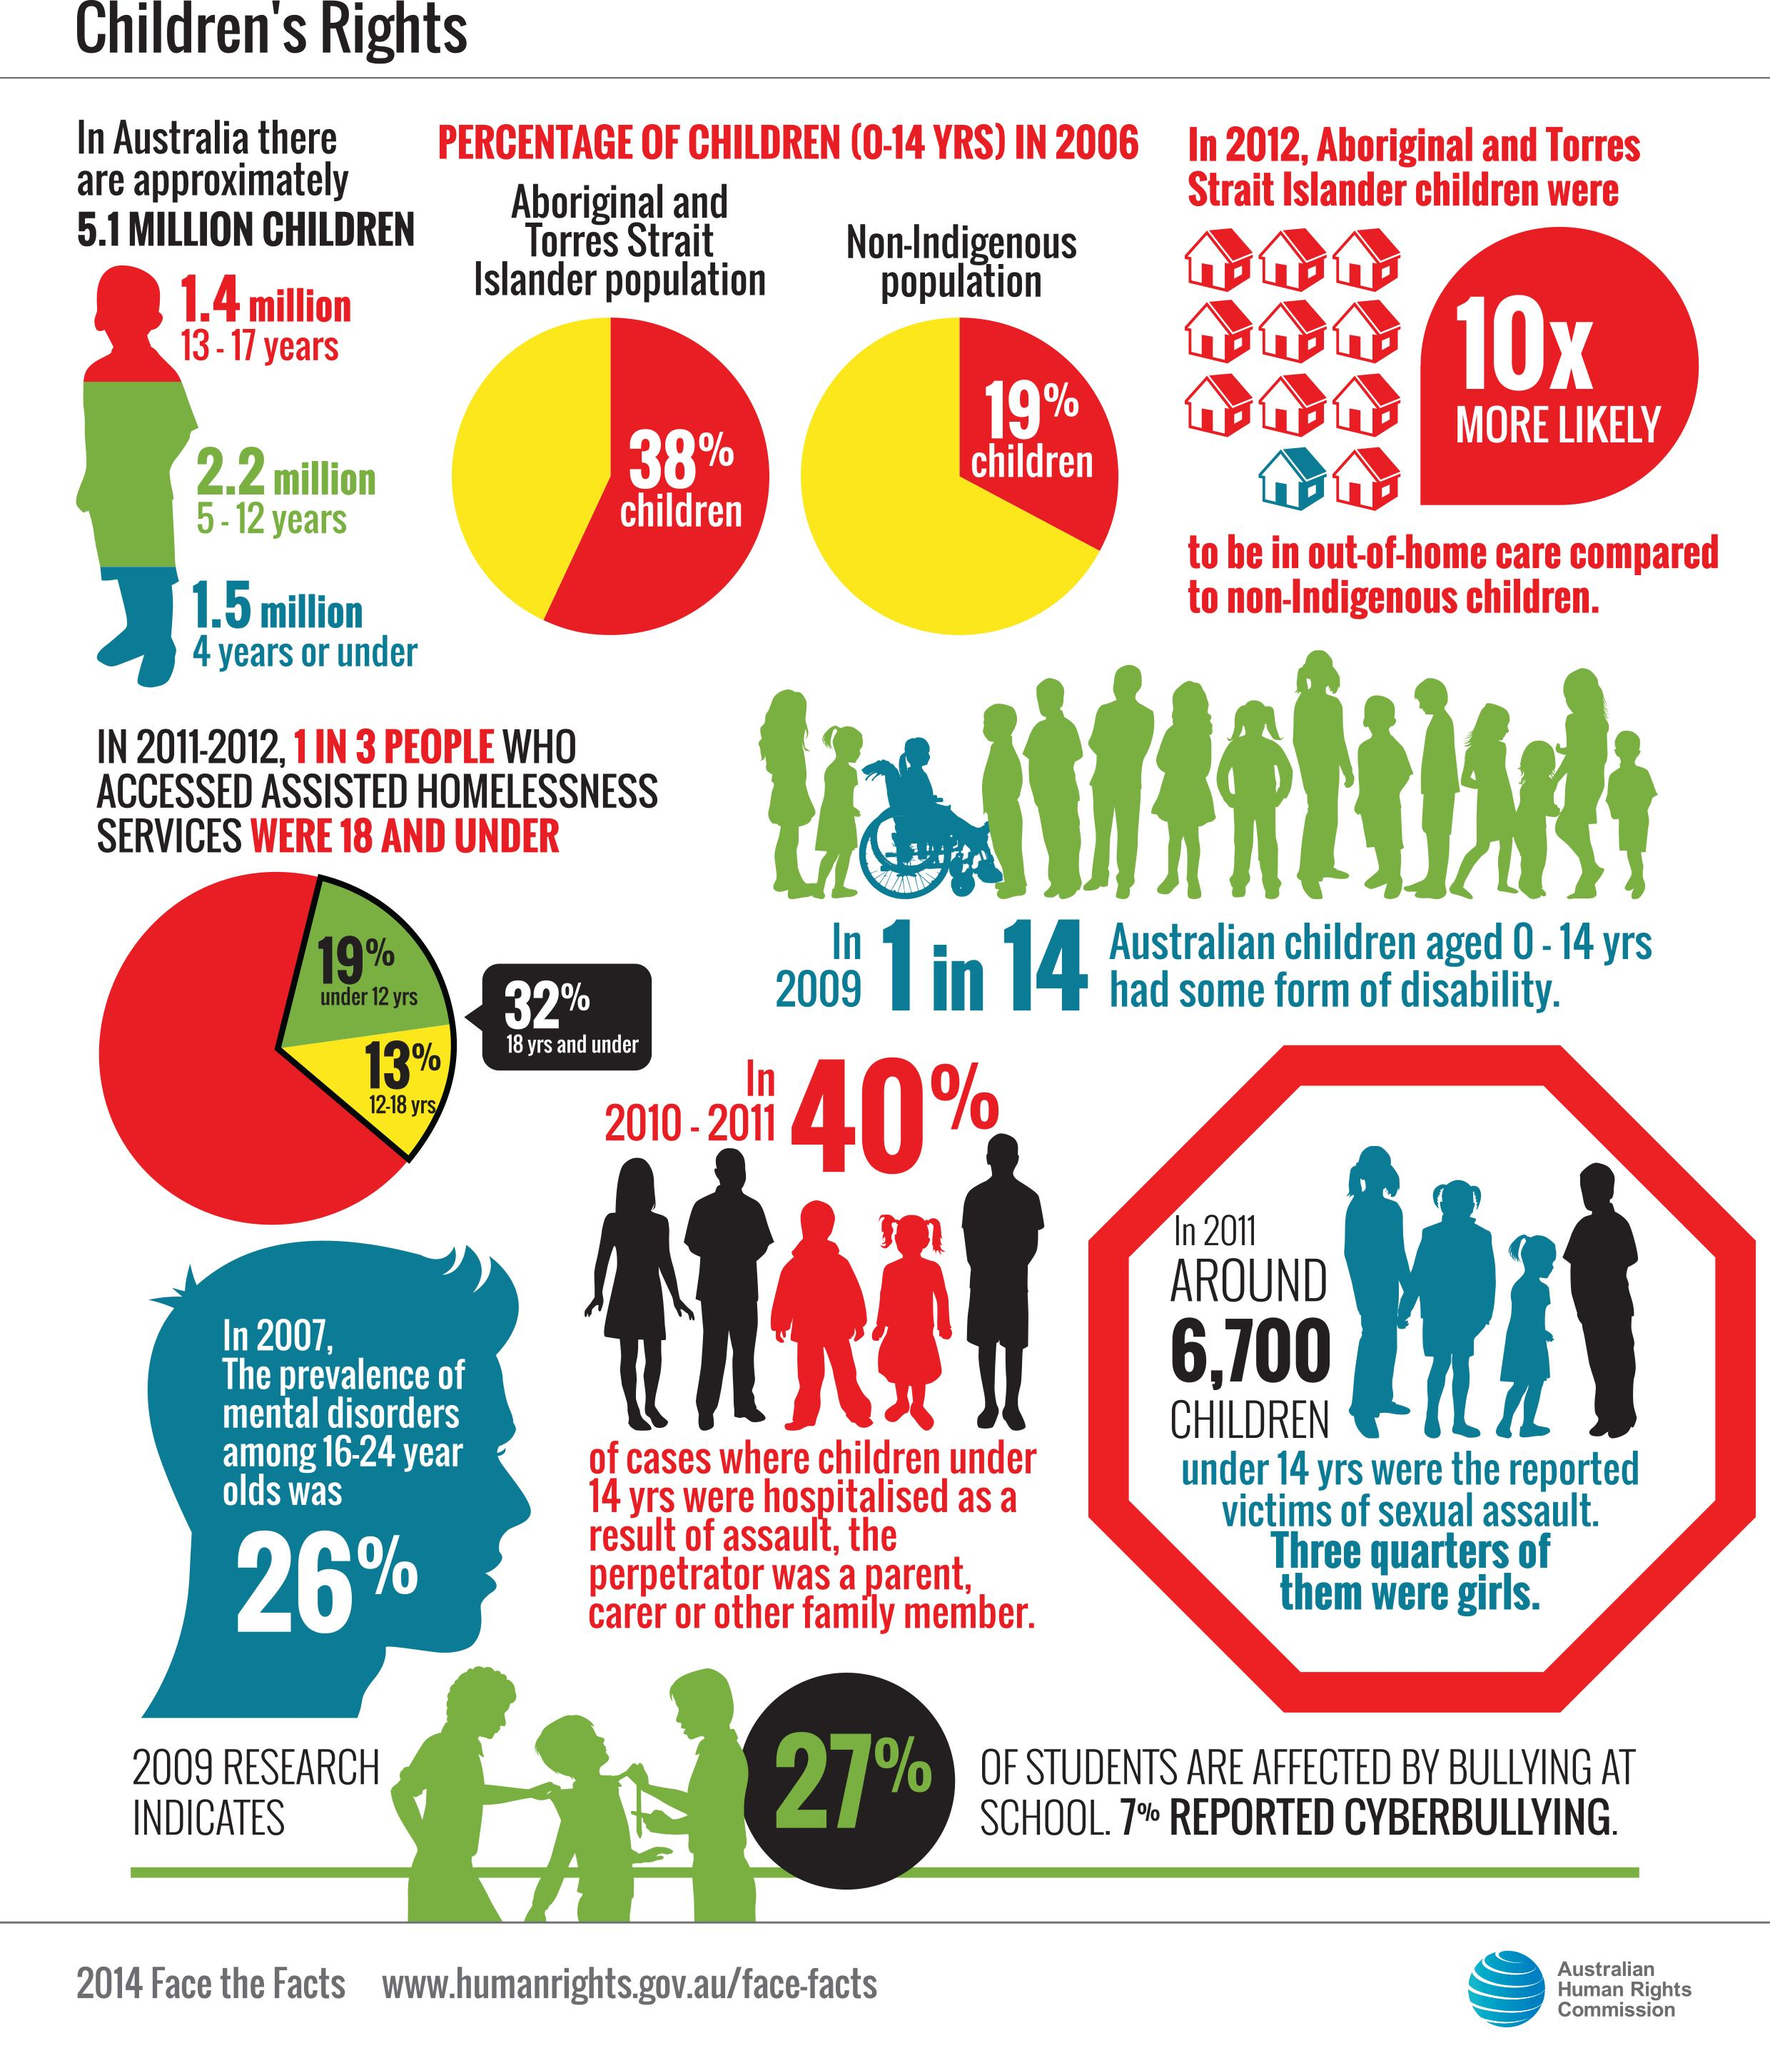Indicate a few pertinent items in this graphic. In 2011-12, 13% of children in the age group of 12-18 years have accessed assisted homelessness services in Australia. According to data, the population of children in the age group of 5-12 years in Australia is approximately 2.2 million. In 2006, 38% of Aboriginal and Torres Strait Islander children in Australia were aged 0-14 years. In Australia during the 2011-12 period, it was found that 19% of children under the age of 12 have accessed assisted homelessness services. In 2006, approximately 19% of children in the age group of 0-14 years in Australia were non-indigenous. 